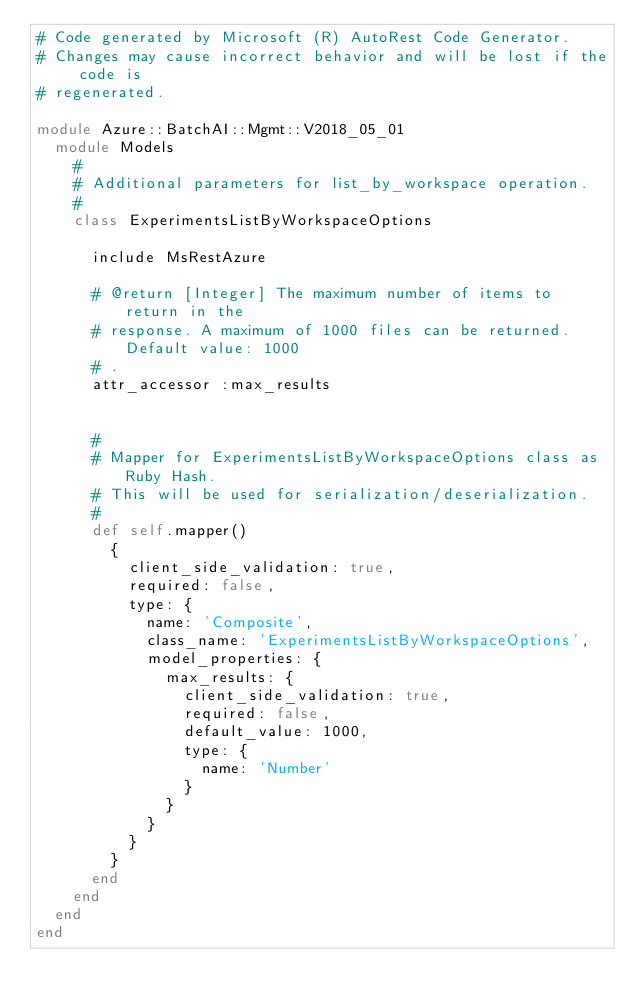<code> <loc_0><loc_0><loc_500><loc_500><_Ruby_># Code generated by Microsoft (R) AutoRest Code Generator.
# Changes may cause incorrect behavior and will be lost if the code is
# regenerated.

module Azure::BatchAI::Mgmt::V2018_05_01
  module Models
    #
    # Additional parameters for list_by_workspace operation.
    #
    class ExperimentsListByWorkspaceOptions

      include MsRestAzure

      # @return [Integer] The maximum number of items to return in the
      # response. A maximum of 1000 files can be returned. Default value: 1000
      # .
      attr_accessor :max_results


      #
      # Mapper for ExperimentsListByWorkspaceOptions class as Ruby Hash.
      # This will be used for serialization/deserialization.
      #
      def self.mapper()
        {
          client_side_validation: true,
          required: false,
          type: {
            name: 'Composite',
            class_name: 'ExperimentsListByWorkspaceOptions',
            model_properties: {
              max_results: {
                client_side_validation: true,
                required: false,
                default_value: 1000,
                type: {
                  name: 'Number'
                }
              }
            }
          }
        }
      end
    end
  end
end
</code> 